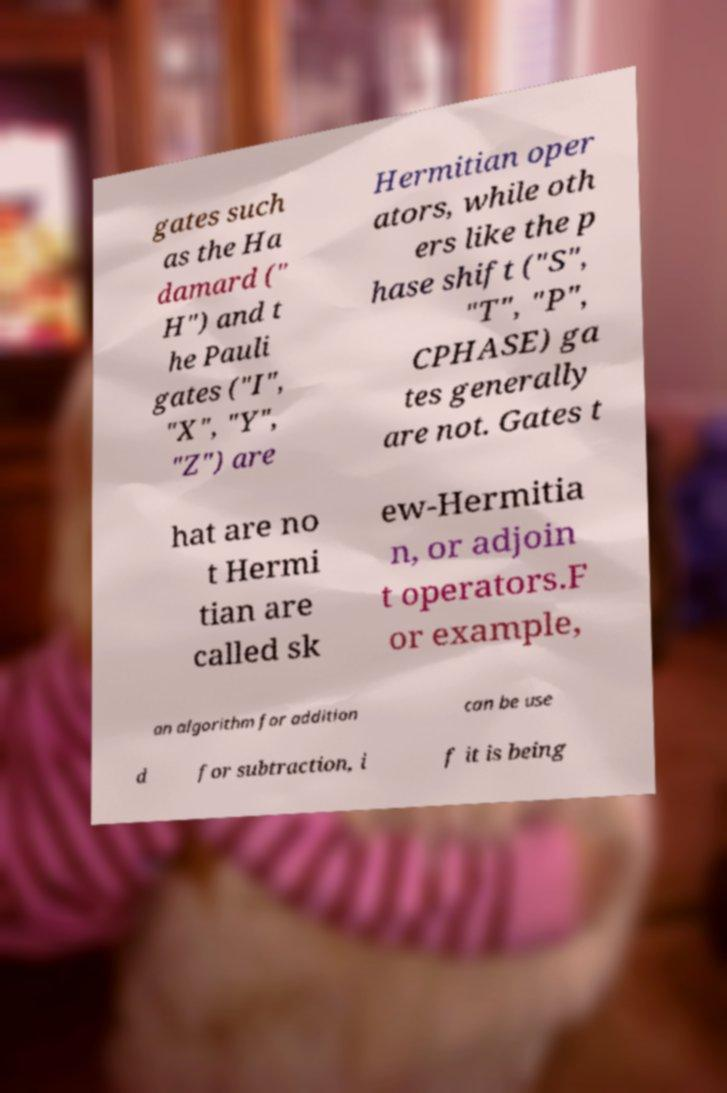Please identify and transcribe the text found in this image. gates such as the Ha damard (" H") and t he Pauli gates ("I", "X", "Y", "Z") are Hermitian oper ators, while oth ers like the p hase shift ("S", "T", "P", CPHASE) ga tes generally are not. Gates t hat are no t Hermi tian are called sk ew-Hermitia n, or adjoin t operators.F or example, an algorithm for addition can be use d for subtraction, i f it is being 